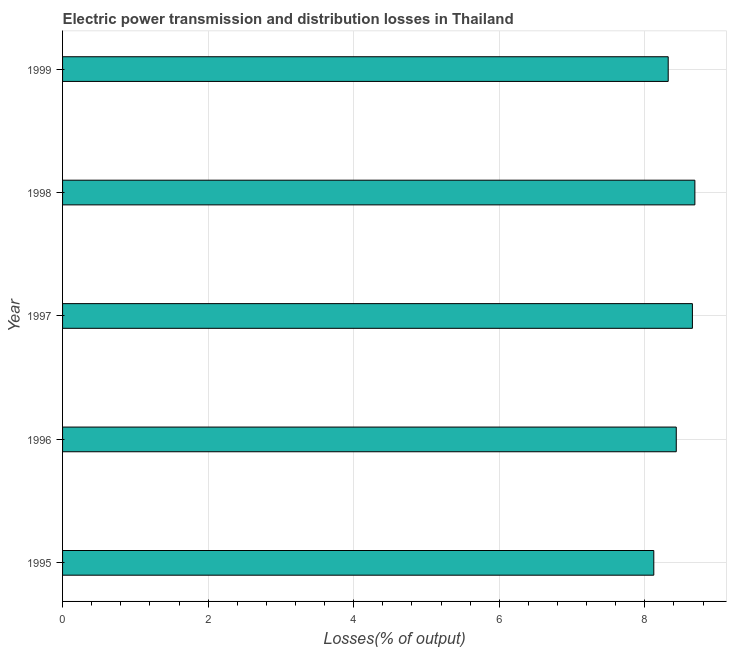What is the title of the graph?
Make the answer very short. Electric power transmission and distribution losses in Thailand. What is the label or title of the X-axis?
Provide a succinct answer. Losses(% of output). What is the electric power transmission and distribution losses in 1999?
Your response must be concise. 8.32. Across all years, what is the maximum electric power transmission and distribution losses?
Provide a short and direct response. 8.69. Across all years, what is the minimum electric power transmission and distribution losses?
Your response must be concise. 8.12. What is the sum of the electric power transmission and distribution losses?
Offer a very short reply. 42.22. What is the difference between the electric power transmission and distribution losses in 1996 and 1999?
Offer a very short reply. 0.11. What is the average electric power transmission and distribution losses per year?
Provide a short and direct response. 8.44. What is the median electric power transmission and distribution losses?
Your response must be concise. 8.43. Do a majority of the years between 1999 and 1997 (inclusive) have electric power transmission and distribution losses greater than 8.4 %?
Provide a succinct answer. Yes. Is the electric power transmission and distribution losses in 1997 less than that in 1998?
Offer a terse response. Yes. Is the difference between the electric power transmission and distribution losses in 1998 and 1999 greater than the difference between any two years?
Your answer should be very brief. No. What is the difference between the highest and the second highest electric power transmission and distribution losses?
Your answer should be compact. 0.03. What is the difference between the highest and the lowest electric power transmission and distribution losses?
Your response must be concise. 0.56. How many bars are there?
Offer a very short reply. 5. What is the Losses(% of output) of 1995?
Give a very brief answer. 8.12. What is the Losses(% of output) of 1996?
Offer a very short reply. 8.43. What is the Losses(% of output) in 1997?
Provide a short and direct response. 8.65. What is the Losses(% of output) in 1998?
Give a very brief answer. 8.69. What is the Losses(% of output) in 1999?
Your answer should be very brief. 8.32. What is the difference between the Losses(% of output) in 1995 and 1996?
Provide a succinct answer. -0.31. What is the difference between the Losses(% of output) in 1995 and 1997?
Your response must be concise. -0.53. What is the difference between the Losses(% of output) in 1995 and 1998?
Your response must be concise. -0.56. What is the difference between the Losses(% of output) in 1995 and 1999?
Your response must be concise. -0.2. What is the difference between the Losses(% of output) in 1996 and 1997?
Provide a succinct answer. -0.22. What is the difference between the Losses(% of output) in 1996 and 1998?
Your answer should be very brief. -0.26. What is the difference between the Losses(% of output) in 1996 and 1999?
Your answer should be very brief. 0.11. What is the difference between the Losses(% of output) in 1997 and 1998?
Your answer should be very brief. -0.03. What is the difference between the Losses(% of output) in 1997 and 1999?
Ensure brevity in your answer.  0.33. What is the difference between the Losses(% of output) in 1998 and 1999?
Give a very brief answer. 0.37. What is the ratio of the Losses(% of output) in 1995 to that in 1997?
Your answer should be very brief. 0.94. What is the ratio of the Losses(% of output) in 1995 to that in 1998?
Provide a succinct answer. 0.94. What is the ratio of the Losses(% of output) in 1996 to that in 1998?
Make the answer very short. 0.97. What is the ratio of the Losses(% of output) in 1997 to that in 1999?
Offer a terse response. 1.04. What is the ratio of the Losses(% of output) in 1998 to that in 1999?
Make the answer very short. 1.04. 